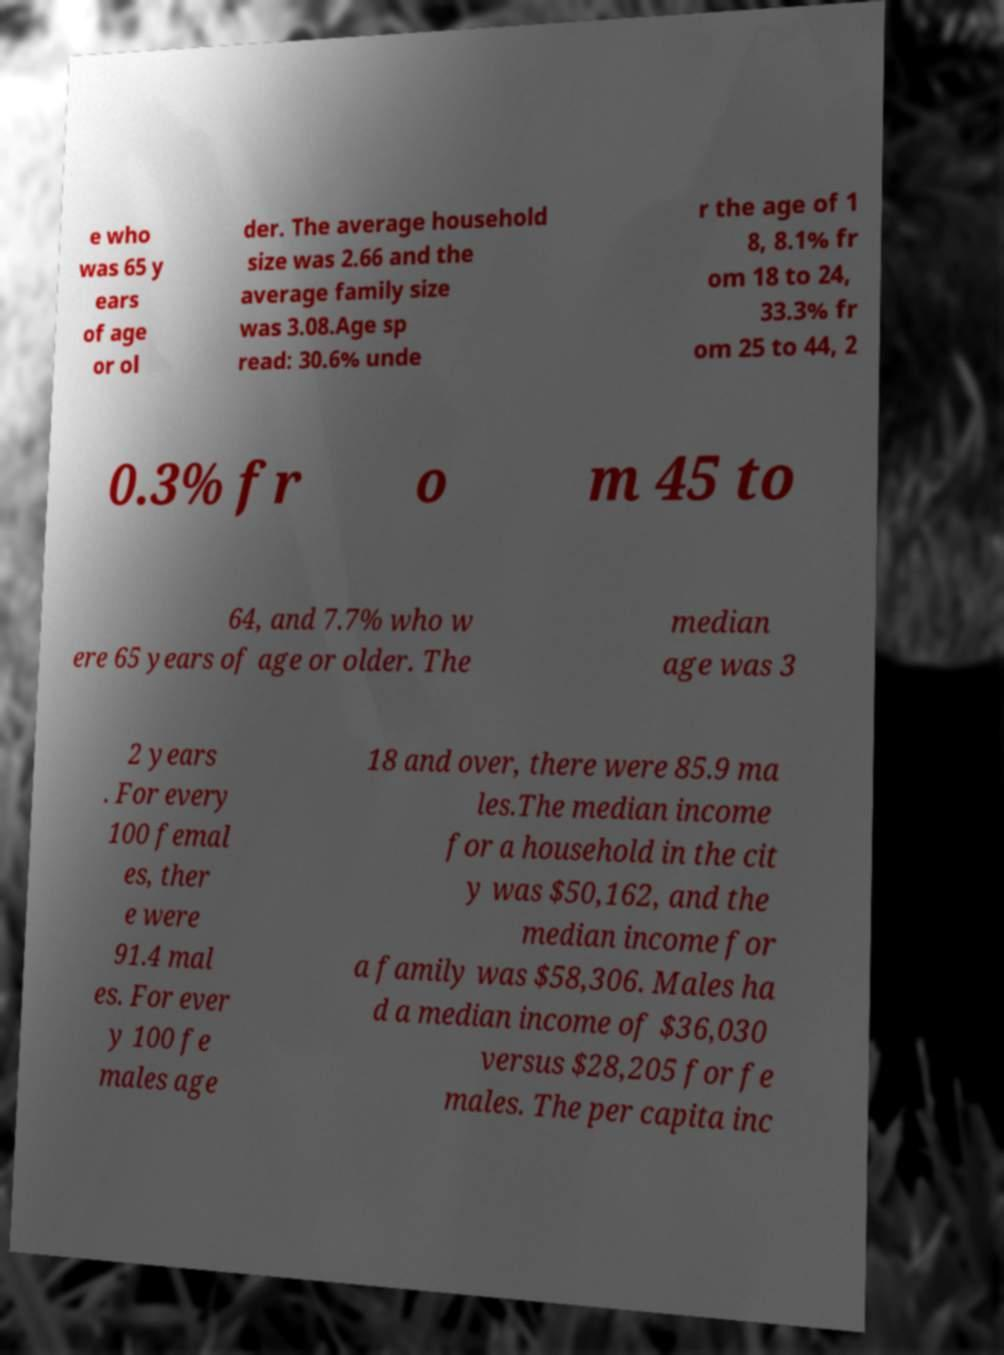Can you read and provide the text displayed in the image?This photo seems to have some interesting text. Can you extract and type it out for me? e who was 65 y ears of age or ol der. The average household size was 2.66 and the average family size was 3.08.Age sp read: 30.6% unde r the age of 1 8, 8.1% fr om 18 to 24, 33.3% fr om 25 to 44, 2 0.3% fr o m 45 to 64, and 7.7% who w ere 65 years of age or older. The median age was 3 2 years . For every 100 femal es, ther e were 91.4 mal es. For ever y 100 fe males age 18 and over, there were 85.9 ma les.The median income for a household in the cit y was $50,162, and the median income for a family was $58,306. Males ha d a median income of $36,030 versus $28,205 for fe males. The per capita inc 